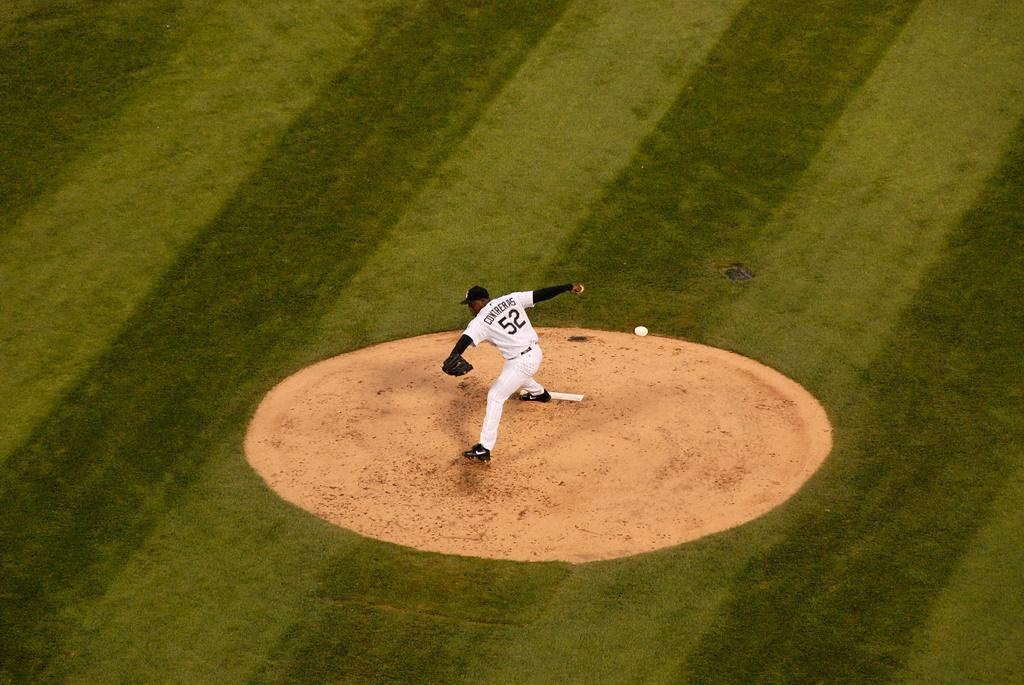What number is this pitcher wearing?
Your answer should be compact. 52. 